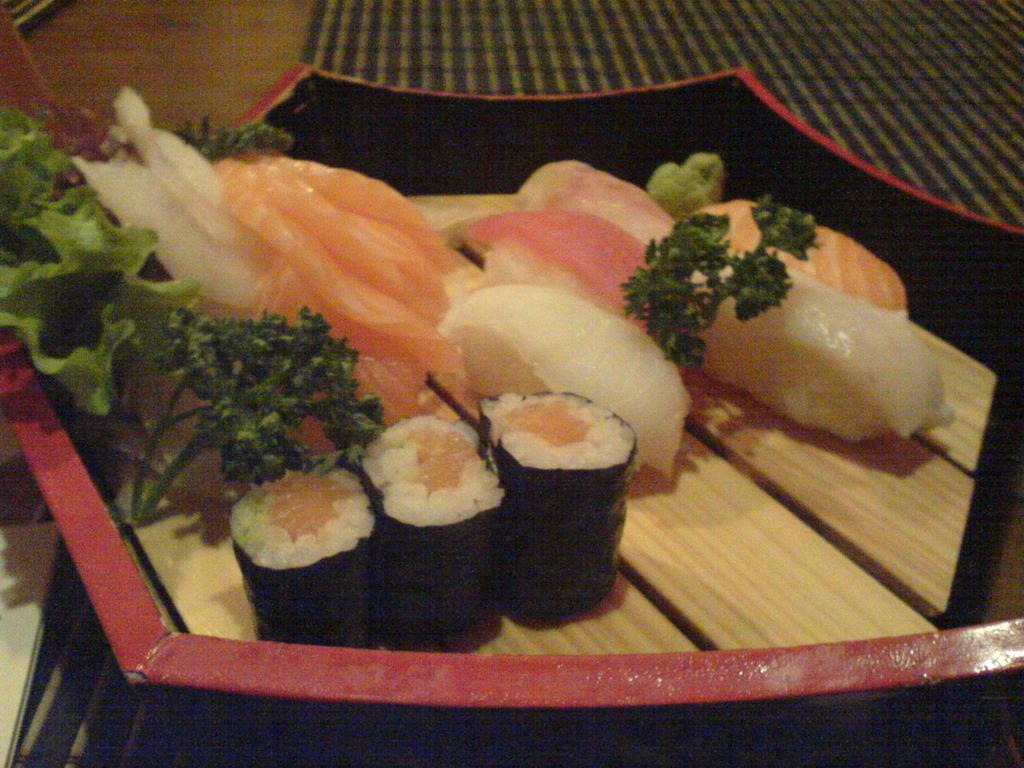What is the main object in the image? There is a bowl in the image. Where is the bowl located? The bowl is placed on a table. What is inside the bowl? The bowl contains food. Can you describe the food in the bowl? The food includes green leaves, meat, and rice. What type of hope can be seen in the image? There is no hope present in the image; it features a bowl of food on a table. How many curves are visible in the image? There is no specific curve mentioned in the provided facts, so it is not possible to determine the number of curves in the image. 